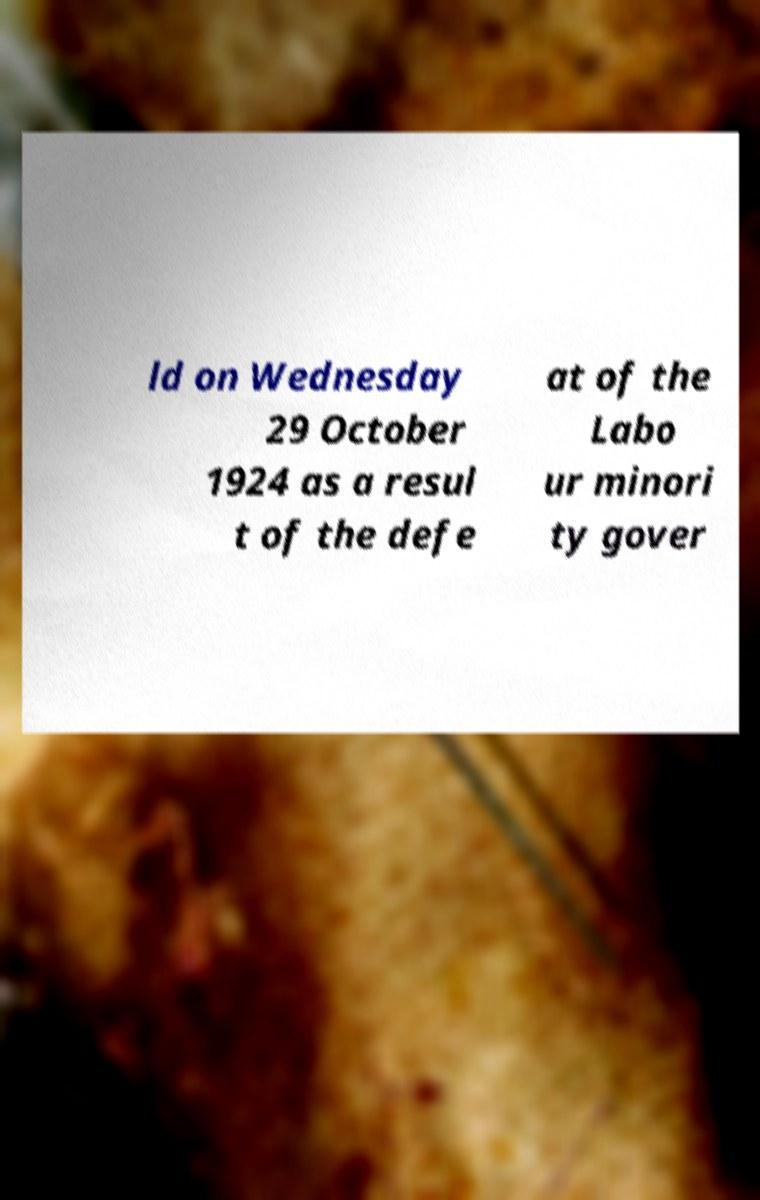I need the written content from this picture converted into text. Can you do that? ld on Wednesday 29 October 1924 as a resul t of the defe at of the Labo ur minori ty gover 